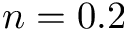<formula> <loc_0><loc_0><loc_500><loc_500>n = 0 . 2</formula> 